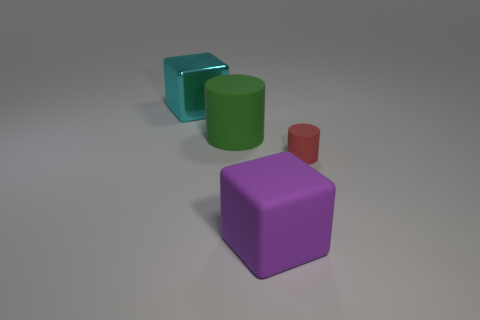Add 4 big blue metal cylinders. How many objects exist? 8 Subtract all purple matte blocks. Subtract all gray shiny cubes. How many objects are left? 3 Add 1 metal blocks. How many metal blocks are left? 2 Add 1 blue metal balls. How many blue metal balls exist? 1 Subtract 0 blue balls. How many objects are left? 4 